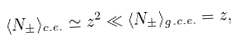<formula> <loc_0><loc_0><loc_500><loc_500>\langle N _ { \pm } \rangle _ { c . e . } \simeq z ^ { 2 } \ll \langle N _ { \pm } \rangle _ { g . c . e . } = z ,</formula> 